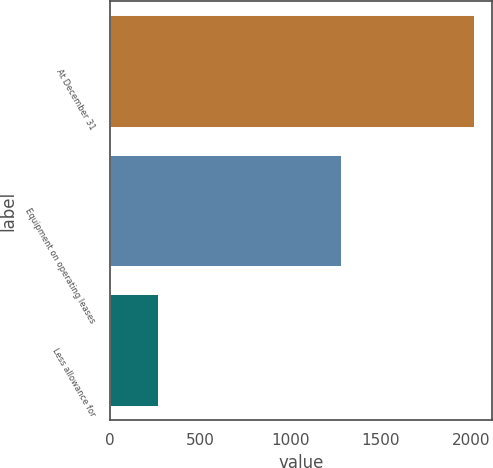Convert chart to OTSL. <chart><loc_0><loc_0><loc_500><loc_500><bar_chart><fcel>At December 31<fcel>Equipment on operating leases<fcel>Less allowance for<nl><fcel>2016<fcel>1282.3<fcel>268.4<nl></chart> 